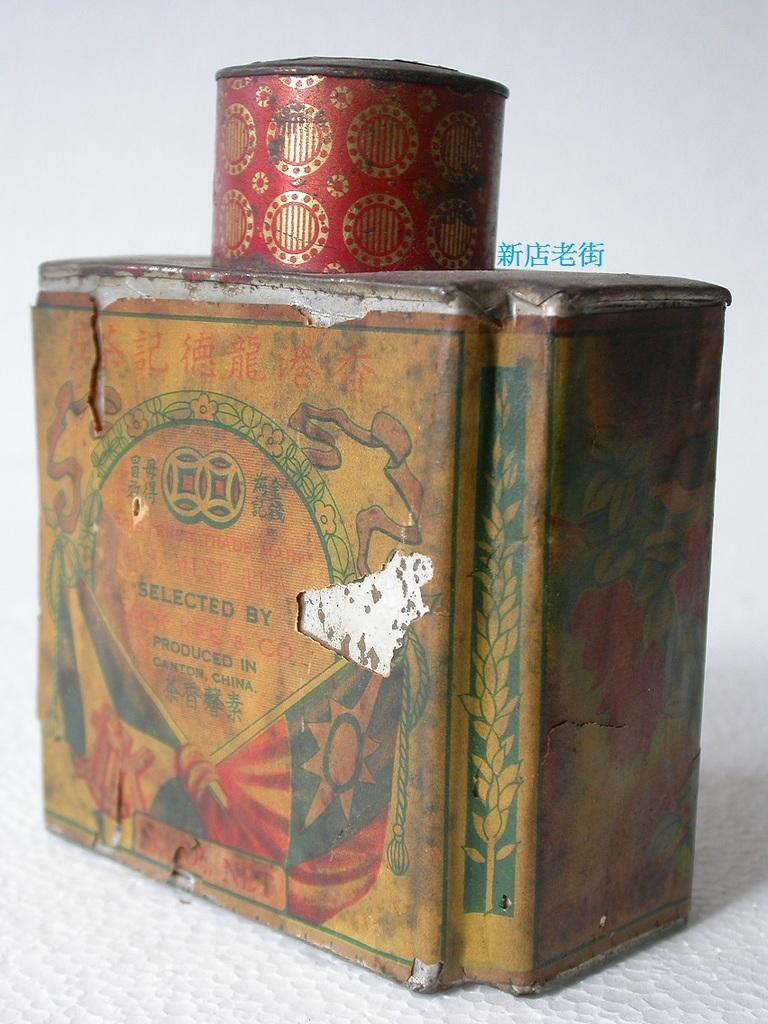<image>
Write a terse but informative summary of the picture. A red tin can on a box labeled produced in Canton, China. 